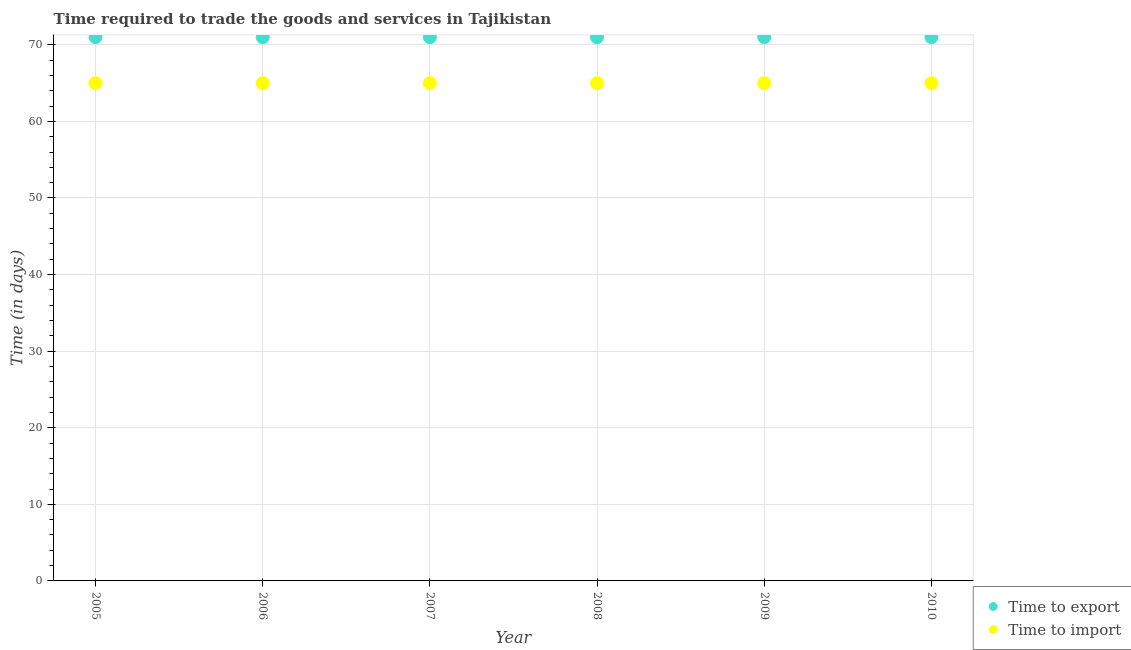How many different coloured dotlines are there?
Give a very brief answer. 2. Is the number of dotlines equal to the number of legend labels?
Make the answer very short. Yes. What is the time to export in 2008?
Provide a short and direct response. 71. Across all years, what is the maximum time to import?
Your answer should be very brief. 65. Across all years, what is the minimum time to import?
Keep it short and to the point. 65. In which year was the time to import maximum?
Make the answer very short. 2005. What is the total time to import in the graph?
Your answer should be very brief. 390. What is the difference between the time to import in 2005 and that in 2006?
Keep it short and to the point. 0. What is the difference between the time to import in 2006 and the time to export in 2008?
Provide a succinct answer. -6. What is the ratio of the time to import in 2007 to that in 2010?
Provide a succinct answer. 1. What is the difference between the highest and the lowest time to import?
Offer a very short reply. 0. In how many years, is the time to export greater than the average time to export taken over all years?
Offer a very short reply. 0. Is the sum of the time to export in 2007 and 2009 greater than the maximum time to import across all years?
Provide a succinct answer. Yes. Does the time to export monotonically increase over the years?
Offer a very short reply. No. Is the time to import strictly greater than the time to export over the years?
Your answer should be very brief. No. How many dotlines are there?
Your answer should be very brief. 2. What is the difference between two consecutive major ticks on the Y-axis?
Keep it short and to the point. 10. How are the legend labels stacked?
Offer a very short reply. Vertical. What is the title of the graph?
Your answer should be compact. Time required to trade the goods and services in Tajikistan. What is the label or title of the Y-axis?
Ensure brevity in your answer.  Time (in days). What is the Time (in days) of Time to import in 2006?
Ensure brevity in your answer.  65. What is the Time (in days) in Time to export in 2007?
Keep it short and to the point. 71. What is the Time (in days) in Time to import in 2007?
Keep it short and to the point. 65. What is the Time (in days) in Time to import in 2009?
Make the answer very short. 65. What is the Time (in days) of Time to export in 2010?
Offer a very short reply. 71. What is the Time (in days) of Time to import in 2010?
Give a very brief answer. 65. What is the total Time (in days) of Time to export in the graph?
Make the answer very short. 426. What is the total Time (in days) in Time to import in the graph?
Offer a terse response. 390. What is the difference between the Time (in days) of Time to import in 2005 and that in 2006?
Ensure brevity in your answer.  0. What is the difference between the Time (in days) in Time to export in 2005 and that in 2008?
Your response must be concise. 0. What is the difference between the Time (in days) in Time to export in 2005 and that in 2009?
Keep it short and to the point. 0. What is the difference between the Time (in days) of Time to import in 2005 and that in 2009?
Offer a very short reply. 0. What is the difference between the Time (in days) in Time to import in 2005 and that in 2010?
Your answer should be compact. 0. What is the difference between the Time (in days) in Time to export in 2006 and that in 2007?
Give a very brief answer. 0. What is the difference between the Time (in days) in Time to import in 2006 and that in 2007?
Make the answer very short. 0. What is the difference between the Time (in days) of Time to export in 2006 and that in 2008?
Ensure brevity in your answer.  0. What is the difference between the Time (in days) of Time to export in 2006 and that in 2009?
Provide a short and direct response. 0. What is the difference between the Time (in days) in Time to import in 2006 and that in 2009?
Your answer should be very brief. 0. What is the difference between the Time (in days) in Time to export in 2007 and that in 2008?
Give a very brief answer. 0. What is the difference between the Time (in days) of Time to export in 2007 and that in 2009?
Your answer should be very brief. 0. What is the difference between the Time (in days) of Time to import in 2007 and that in 2009?
Your answer should be very brief. 0. What is the difference between the Time (in days) of Time to export in 2008 and that in 2010?
Make the answer very short. 0. What is the difference between the Time (in days) of Time to import in 2008 and that in 2010?
Offer a terse response. 0. What is the difference between the Time (in days) of Time to export in 2005 and the Time (in days) of Time to import in 2007?
Your response must be concise. 6. What is the difference between the Time (in days) in Time to export in 2005 and the Time (in days) in Time to import in 2008?
Provide a succinct answer. 6. What is the difference between the Time (in days) in Time to export in 2005 and the Time (in days) in Time to import in 2009?
Offer a very short reply. 6. What is the difference between the Time (in days) of Time to export in 2005 and the Time (in days) of Time to import in 2010?
Make the answer very short. 6. What is the difference between the Time (in days) in Time to export in 2006 and the Time (in days) in Time to import in 2007?
Keep it short and to the point. 6. What is the difference between the Time (in days) of Time to export in 2007 and the Time (in days) of Time to import in 2009?
Offer a terse response. 6. What is the difference between the Time (in days) of Time to export in 2007 and the Time (in days) of Time to import in 2010?
Ensure brevity in your answer.  6. What is the difference between the Time (in days) in Time to export in 2008 and the Time (in days) in Time to import in 2009?
Ensure brevity in your answer.  6. What is the difference between the Time (in days) in Time to export in 2008 and the Time (in days) in Time to import in 2010?
Provide a short and direct response. 6. What is the average Time (in days) in Time to export per year?
Offer a terse response. 71. In the year 2005, what is the difference between the Time (in days) of Time to export and Time (in days) of Time to import?
Make the answer very short. 6. In the year 2007, what is the difference between the Time (in days) in Time to export and Time (in days) in Time to import?
Ensure brevity in your answer.  6. In the year 2008, what is the difference between the Time (in days) in Time to export and Time (in days) in Time to import?
Give a very brief answer. 6. What is the ratio of the Time (in days) of Time to import in 2005 to that in 2007?
Make the answer very short. 1. What is the ratio of the Time (in days) in Time to import in 2005 to that in 2008?
Ensure brevity in your answer.  1. What is the ratio of the Time (in days) of Time to export in 2005 to that in 2009?
Your answer should be very brief. 1. What is the ratio of the Time (in days) in Time to import in 2005 to that in 2009?
Give a very brief answer. 1. What is the ratio of the Time (in days) in Time to export in 2005 to that in 2010?
Ensure brevity in your answer.  1. What is the ratio of the Time (in days) in Time to import in 2005 to that in 2010?
Provide a short and direct response. 1. What is the ratio of the Time (in days) in Time to export in 2006 to that in 2007?
Your response must be concise. 1. What is the ratio of the Time (in days) of Time to import in 2006 to that in 2007?
Provide a short and direct response. 1. What is the ratio of the Time (in days) in Time to export in 2006 to that in 2008?
Give a very brief answer. 1. What is the ratio of the Time (in days) in Time to import in 2006 to that in 2008?
Your answer should be very brief. 1. What is the ratio of the Time (in days) of Time to export in 2006 to that in 2009?
Your answer should be compact. 1. What is the ratio of the Time (in days) of Time to export in 2006 to that in 2010?
Your response must be concise. 1. What is the ratio of the Time (in days) in Time to export in 2007 to that in 2008?
Give a very brief answer. 1. What is the ratio of the Time (in days) of Time to import in 2007 to that in 2008?
Offer a very short reply. 1. What is the ratio of the Time (in days) of Time to export in 2007 to that in 2010?
Your answer should be compact. 1. What is the ratio of the Time (in days) of Time to import in 2007 to that in 2010?
Offer a terse response. 1. What is the ratio of the Time (in days) of Time to import in 2008 to that in 2009?
Keep it short and to the point. 1. What is the ratio of the Time (in days) in Time to export in 2008 to that in 2010?
Offer a very short reply. 1. What is the difference between the highest and the second highest Time (in days) in Time to export?
Provide a short and direct response. 0. What is the difference between the highest and the lowest Time (in days) in Time to export?
Ensure brevity in your answer.  0. 